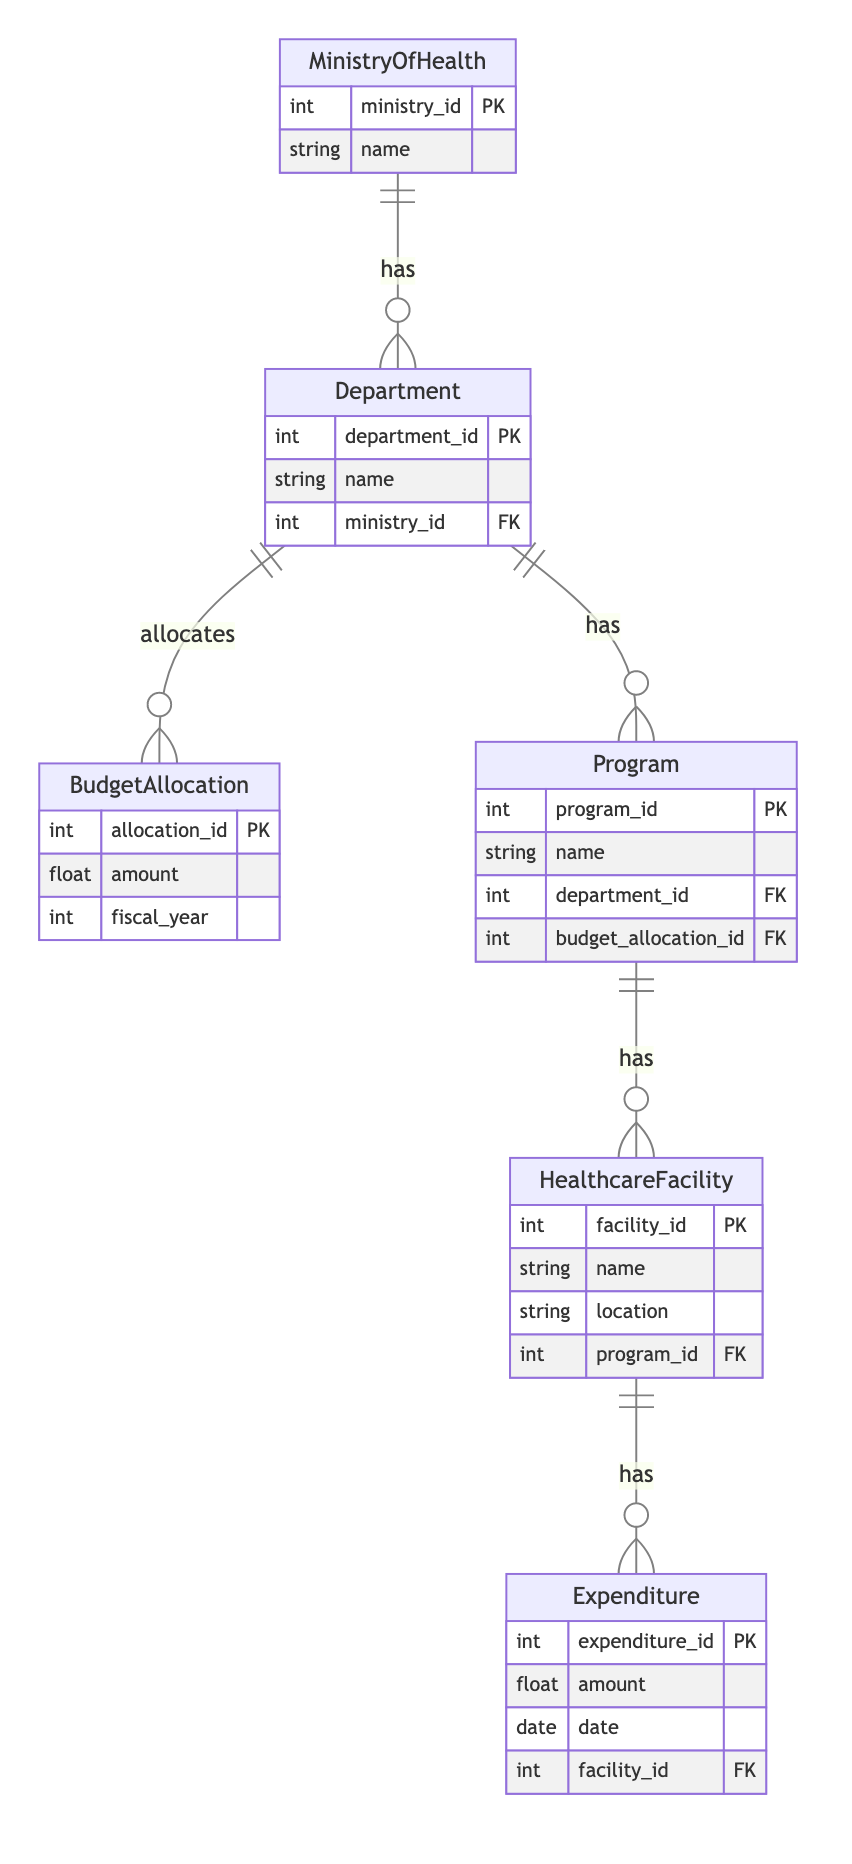What is the primary entity in this diagram? The diagram depicts the Ministry of Health as the primary entity, as it is the starting point and has relationships with other entities.
Answer: Ministry of Health How many entities are represented in the diagram? The diagram includes six distinct entities: MinistryOfHealth, Department, BudgetAllocation, Program, HealthcareFacility, and Expenditure, totaling six.
Answer: Six What relationship connects the Ministry of Health and Departments? The relationship between the Ministry of Health and Departments is characterized as "has," indicating that the ministry has multiple departments under its administration.
Answer: has Which entity is responsible for budget allocation? The Department entity is responsible for budget allocation, as it directly links to the BudgetAllocation entity through the relationship defined in the diagram.
Answer: Department How many entities can a single Department have according to the relationships described? Each Department can be associated with multiple Programs, BudgetAllocations, and can influence multiple HealthcareFacilities through its programs, indicating a one-to-many relationship in each case.
Answer: Many What type of relationship is between Program and HealthcareFacility? The relationship type between Program and HealthcareFacility is "has," indicating that each program encompasses various healthcare facilities.
Answer: has What is the relationship between Department and BudgetAllocation? The relationship defined by the diagram is "allocates," which specifies that each Department allocates a specific amount of budget for its operations.
Answer: allocates In total, how many direct connections does the Department entity have with other entities? The Department entity has three direct connections: to BudgetAllocation, to Program, and to the Ministry of Health, making it highly interconnected in this context.
Answer: Three What is the main function of the Expenditure entity in the diagram? The Expenditure entity's primary function is to record expenditures related to different HealthcareFacilities, allowing tracking and management of spending in the healthcare system.
Answer: Record expenditures 